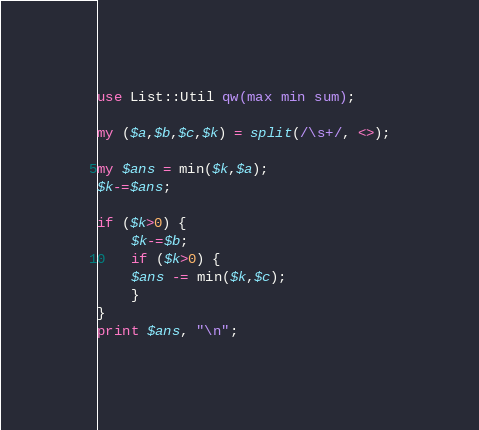<code> <loc_0><loc_0><loc_500><loc_500><_Perl_>use List::Util qw(max min sum);

my ($a,$b,$c,$k) = split(/\s+/, <>);

my $ans = min($k,$a);
$k-=$ans;

if ($k>0) {
    $k-=$b;
    if ($k>0) {
	$ans -= min($k,$c);
    }
}
print $ans, "\n";
</code> 